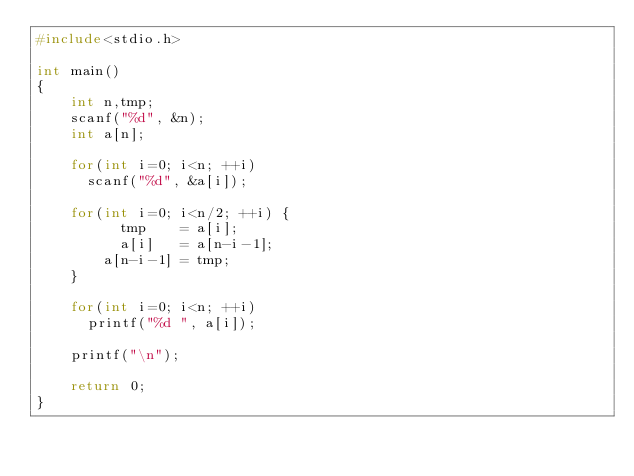Convert code to text. <code><loc_0><loc_0><loc_500><loc_500><_C_>#include<stdio.h>

int main()
{
    int n,tmp;
    scanf("%d", &n);
    int a[n];

    for(int i=0; i<n; ++i)
      scanf("%d", &a[i]);

    for(int i=0; i<n/2; ++i) {
          tmp    = a[i];
          a[i]   = a[n-i-1];
        a[n-i-1] = tmp;
    }

    for(int i=0; i<n; ++i)
      printf("%d ", a[i]);

    printf("\n");

    return 0;
}

</code> 